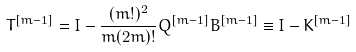Convert formula to latex. <formula><loc_0><loc_0><loc_500><loc_500>T ^ { [ m - 1 ] } = I - \frac { ( m ! ) ^ { 2 } } { m ( 2 m ) ! } Q ^ { [ m - 1 ] } B ^ { [ m - 1 ] } \equiv I - K ^ { [ m - 1 ] }</formula> 